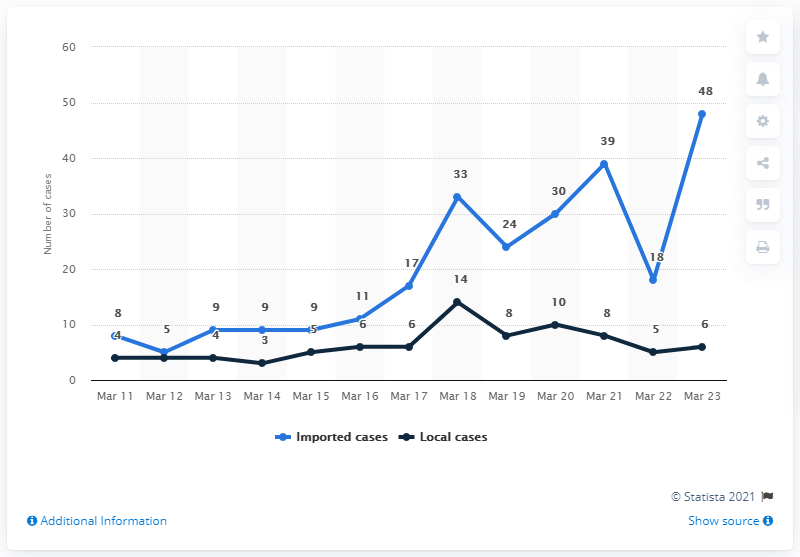List a handful of essential elements in this visual. On March 23, 2020, there were 48 imported cases of COVID-19. 